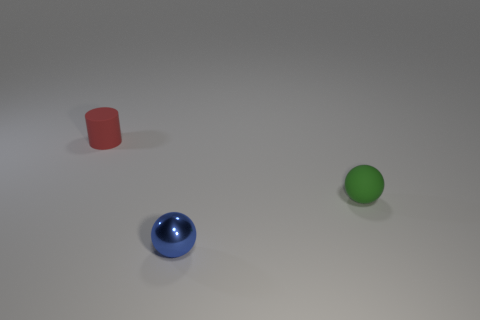Add 2 tiny rubber cylinders. How many objects exist? 5 Subtract all spheres. How many objects are left? 1 Subtract all blue metal objects. Subtract all cyan spheres. How many objects are left? 2 Add 1 tiny cylinders. How many tiny cylinders are left? 2 Add 2 tiny balls. How many tiny balls exist? 4 Subtract 1 green spheres. How many objects are left? 2 